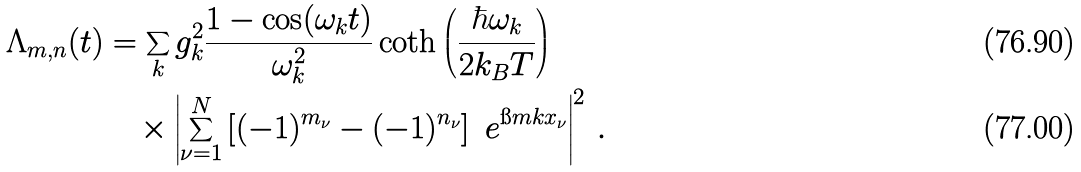<formula> <loc_0><loc_0><loc_500><loc_500>\Lambda _ { m , n } ( t ) & = \sum _ { k } g _ { k } ^ { 2 } \frac { 1 - \cos ( \omega _ { k } t ) } { \omega _ { k } ^ { 2 } } \coth \left ( \frac { \hbar { \omega } _ { k } } { 2 k _ { B } T } \right ) \\ & \quad \times \left | \sum _ { \nu = 1 } ^ { N } \left [ ( - 1 ) ^ { m _ { \nu } } - ( - 1 ) ^ { n _ { \nu } } \right ] \ e ^ { \i m k x _ { \nu } } \right | ^ { 2 } \, .</formula> 